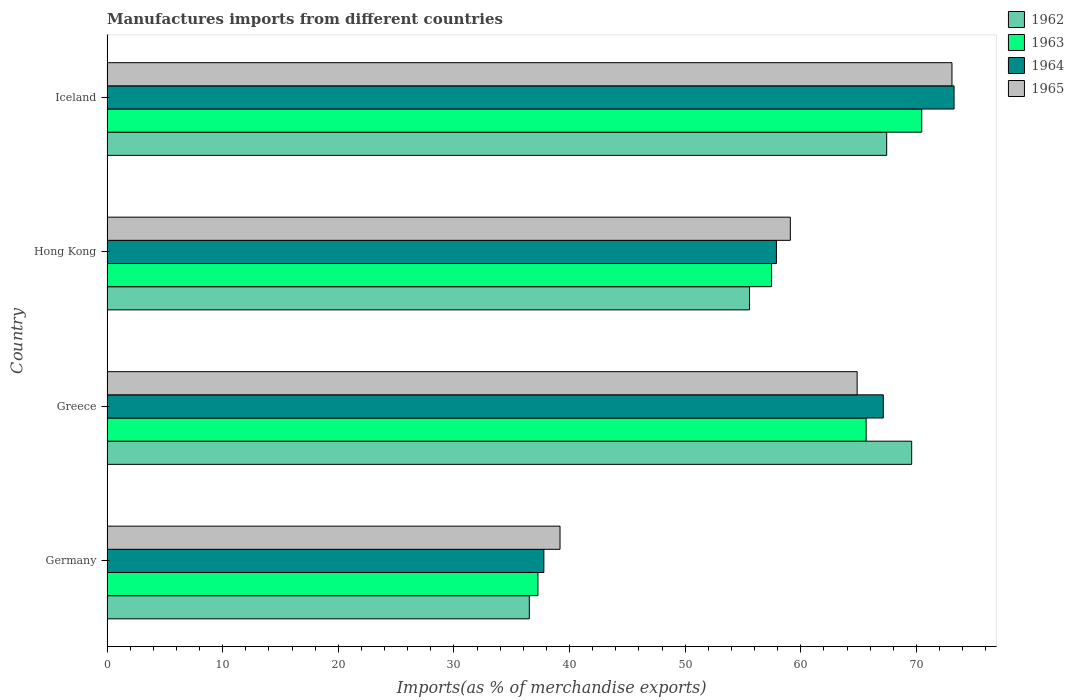How many different coloured bars are there?
Offer a terse response. 4. How many groups of bars are there?
Offer a very short reply. 4. Are the number of bars on each tick of the Y-axis equal?
Your answer should be very brief. Yes. What is the label of the 4th group of bars from the top?
Offer a very short reply. Germany. What is the percentage of imports to different countries in 1962 in Hong Kong?
Your response must be concise. 55.56. Across all countries, what is the maximum percentage of imports to different countries in 1963?
Give a very brief answer. 70.45. Across all countries, what is the minimum percentage of imports to different countries in 1965?
Provide a short and direct response. 39.18. In which country was the percentage of imports to different countries in 1963 maximum?
Provide a succinct answer. Iceland. In which country was the percentage of imports to different countries in 1965 minimum?
Provide a short and direct response. Germany. What is the total percentage of imports to different countries in 1965 in the graph?
Provide a succinct answer. 236.2. What is the difference between the percentage of imports to different countries in 1964 in Hong Kong and that in Iceland?
Provide a short and direct response. -15.36. What is the difference between the percentage of imports to different countries in 1964 in Greece and the percentage of imports to different countries in 1965 in Iceland?
Give a very brief answer. -5.94. What is the average percentage of imports to different countries in 1965 per country?
Offer a terse response. 59.05. What is the difference between the percentage of imports to different countries in 1962 and percentage of imports to different countries in 1965 in Hong Kong?
Your response must be concise. -3.53. In how many countries, is the percentage of imports to different countries in 1965 greater than 62 %?
Your answer should be very brief. 2. What is the ratio of the percentage of imports to different countries in 1962 in Hong Kong to that in Iceland?
Your response must be concise. 0.82. What is the difference between the highest and the second highest percentage of imports to different countries in 1962?
Your response must be concise. 2.16. What is the difference between the highest and the lowest percentage of imports to different countries in 1963?
Your response must be concise. 33.19. Is the sum of the percentage of imports to different countries in 1962 in Germany and Hong Kong greater than the maximum percentage of imports to different countries in 1963 across all countries?
Make the answer very short. Yes. What does the 1st bar from the top in Hong Kong represents?
Provide a succinct answer. 1965. What does the 3rd bar from the bottom in Greece represents?
Offer a very short reply. 1964. Is it the case that in every country, the sum of the percentage of imports to different countries in 1962 and percentage of imports to different countries in 1964 is greater than the percentage of imports to different countries in 1965?
Make the answer very short. Yes. Are all the bars in the graph horizontal?
Offer a terse response. Yes. How many countries are there in the graph?
Offer a very short reply. 4. What is the difference between two consecutive major ticks on the X-axis?
Offer a terse response. 10. Does the graph contain grids?
Keep it short and to the point. No. How are the legend labels stacked?
Offer a very short reply. Vertical. What is the title of the graph?
Offer a very short reply. Manufactures imports from different countries. Does "1980" appear as one of the legend labels in the graph?
Your response must be concise. No. What is the label or title of the X-axis?
Your answer should be compact. Imports(as % of merchandise exports). What is the label or title of the Y-axis?
Offer a very short reply. Country. What is the Imports(as % of merchandise exports) in 1962 in Germany?
Keep it short and to the point. 36.52. What is the Imports(as % of merchandise exports) in 1963 in Germany?
Your answer should be very brief. 37.26. What is the Imports(as % of merchandise exports) of 1964 in Germany?
Your answer should be very brief. 37.78. What is the Imports(as % of merchandise exports) in 1965 in Germany?
Keep it short and to the point. 39.18. What is the Imports(as % of merchandise exports) of 1962 in Greece?
Your response must be concise. 69.58. What is the Imports(as % of merchandise exports) of 1963 in Greece?
Your answer should be very brief. 65.65. What is the Imports(as % of merchandise exports) of 1964 in Greece?
Offer a terse response. 67.13. What is the Imports(as % of merchandise exports) of 1965 in Greece?
Keep it short and to the point. 64.87. What is the Imports(as % of merchandise exports) of 1962 in Hong Kong?
Your response must be concise. 55.56. What is the Imports(as % of merchandise exports) of 1963 in Hong Kong?
Offer a very short reply. 57.47. What is the Imports(as % of merchandise exports) in 1964 in Hong Kong?
Ensure brevity in your answer.  57.89. What is the Imports(as % of merchandise exports) of 1965 in Hong Kong?
Keep it short and to the point. 59.09. What is the Imports(as % of merchandise exports) of 1962 in Iceland?
Provide a short and direct response. 67.42. What is the Imports(as % of merchandise exports) in 1963 in Iceland?
Provide a succinct answer. 70.45. What is the Imports(as % of merchandise exports) in 1964 in Iceland?
Your answer should be compact. 73.25. What is the Imports(as % of merchandise exports) of 1965 in Iceland?
Provide a short and direct response. 73.07. Across all countries, what is the maximum Imports(as % of merchandise exports) in 1962?
Your response must be concise. 69.58. Across all countries, what is the maximum Imports(as % of merchandise exports) of 1963?
Give a very brief answer. 70.45. Across all countries, what is the maximum Imports(as % of merchandise exports) in 1964?
Offer a terse response. 73.25. Across all countries, what is the maximum Imports(as % of merchandise exports) in 1965?
Your response must be concise. 73.07. Across all countries, what is the minimum Imports(as % of merchandise exports) of 1962?
Ensure brevity in your answer.  36.52. Across all countries, what is the minimum Imports(as % of merchandise exports) of 1963?
Your answer should be very brief. 37.26. Across all countries, what is the minimum Imports(as % of merchandise exports) of 1964?
Your answer should be very brief. 37.78. Across all countries, what is the minimum Imports(as % of merchandise exports) in 1965?
Provide a short and direct response. 39.18. What is the total Imports(as % of merchandise exports) in 1962 in the graph?
Your response must be concise. 229.09. What is the total Imports(as % of merchandise exports) of 1963 in the graph?
Provide a succinct answer. 230.83. What is the total Imports(as % of merchandise exports) of 1964 in the graph?
Make the answer very short. 236.05. What is the total Imports(as % of merchandise exports) in 1965 in the graph?
Make the answer very short. 236.2. What is the difference between the Imports(as % of merchandise exports) of 1962 in Germany and that in Greece?
Your answer should be compact. -33.06. What is the difference between the Imports(as % of merchandise exports) of 1963 in Germany and that in Greece?
Ensure brevity in your answer.  -28.38. What is the difference between the Imports(as % of merchandise exports) in 1964 in Germany and that in Greece?
Offer a terse response. -29.35. What is the difference between the Imports(as % of merchandise exports) of 1965 in Germany and that in Greece?
Offer a terse response. -25.69. What is the difference between the Imports(as % of merchandise exports) of 1962 in Germany and that in Hong Kong?
Offer a very short reply. -19.04. What is the difference between the Imports(as % of merchandise exports) in 1963 in Germany and that in Hong Kong?
Your answer should be very brief. -20.2. What is the difference between the Imports(as % of merchandise exports) of 1964 in Germany and that in Hong Kong?
Your response must be concise. -20.11. What is the difference between the Imports(as % of merchandise exports) of 1965 in Germany and that in Hong Kong?
Give a very brief answer. -19.91. What is the difference between the Imports(as % of merchandise exports) of 1962 in Germany and that in Iceland?
Keep it short and to the point. -30.9. What is the difference between the Imports(as % of merchandise exports) in 1963 in Germany and that in Iceland?
Keep it short and to the point. -33.19. What is the difference between the Imports(as % of merchandise exports) in 1964 in Germany and that in Iceland?
Give a very brief answer. -35.47. What is the difference between the Imports(as % of merchandise exports) of 1965 in Germany and that in Iceland?
Offer a terse response. -33.89. What is the difference between the Imports(as % of merchandise exports) in 1962 in Greece and that in Hong Kong?
Your answer should be compact. 14.02. What is the difference between the Imports(as % of merchandise exports) in 1963 in Greece and that in Hong Kong?
Provide a succinct answer. 8.18. What is the difference between the Imports(as % of merchandise exports) in 1964 in Greece and that in Hong Kong?
Offer a very short reply. 9.24. What is the difference between the Imports(as % of merchandise exports) of 1965 in Greece and that in Hong Kong?
Give a very brief answer. 5.78. What is the difference between the Imports(as % of merchandise exports) of 1962 in Greece and that in Iceland?
Provide a short and direct response. 2.16. What is the difference between the Imports(as % of merchandise exports) in 1963 in Greece and that in Iceland?
Provide a short and direct response. -4.81. What is the difference between the Imports(as % of merchandise exports) in 1964 in Greece and that in Iceland?
Provide a succinct answer. -6.12. What is the difference between the Imports(as % of merchandise exports) of 1965 in Greece and that in Iceland?
Ensure brevity in your answer.  -8.2. What is the difference between the Imports(as % of merchandise exports) of 1962 in Hong Kong and that in Iceland?
Provide a succinct answer. -11.86. What is the difference between the Imports(as % of merchandise exports) in 1963 in Hong Kong and that in Iceland?
Keep it short and to the point. -12.98. What is the difference between the Imports(as % of merchandise exports) in 1964 in Hong Kong and that in Iceland?
Keep it short and to the point. -15.36. What is the difference between the Imports(as % of merchandise exports) of 1965 in Hong Kong and that in Iceland?
Ensure brevity in your answer.  -13.98. What is the difference between the Imports(as % of merchandise exports) in 1962 in Germany and the Imports(as % of merchandise exports) in 1963 in Greece?
Your response must be concise. -29.13. What is the difference between the Imports(as % of merchandise exports) in 1962 in Germany and the Imports(as % of merchandise exports) in 1964 in Greece?
Provide a succinct answer. -30.61. What is the difference between the Imports(as % of merchandise exports) in 1962 in Germany and the Imports(as % of merchandise exports) in 1965 in Greece?
Keep it short and to the point. -28.35. What is the difference between the Imports(as % of merchandise exports) in 1963 in Germany and the Imports(as % of merchandise exports) in 1964 in Greece?
Offer a terse response. -29.87. What is the difference between the Imports(as % of merchandise exports) of 1963 in Germany and the Imports(as % of merchandise exports) of 1965 in Greece?
Keep it short and to the point. -27.6. What is the difference between the Imports(as % of merchandise exports) in 1964 in Germany and the Imports(as % of merchandise exports) in 1965 in Greece?
Make the answer very short. -27.09. What is the difference between the Imports(as % of merchandise exports) of 1962 in Germany and the Imports(as % of merchandise exports) of 1963 in Hong Kong?
Provide a succinct answer. -20.95. What is the difference between the Imports(as % of merchandise exports) of 1962 in Germany and the Imports(as % of merchandise exports) of 1964 in Hong Kong?
Give a very brief answer. -21.37. What is the difference between the Imports(as % of merchandise exports) of 1962 in Germany and the Imports(as % of merchandise exports) of 1965 in Hong Kong?
Provide a short and direct response. -22.57. What is the difference between the Imports(as % of merchandise exports) in 1963 in Germany and the Imports(as % of merchandise exports) in 1964 in Hong Kong?
Your answer should be compact. -20.62. What is the difference between the Imports(as % of merchandise exports) of 1963 in Germany and the Imports(as % of merchandise exports) of 1965 in Hong Kong?
Your answer should be very brief. -21.83. What is the difference between the Imports(as % of merchandise exports) of 1964 in Germany and the Imports(as % of merchandise exports) of 1965 in Hong Kong?
Make the answer very short. -21.31. What is the difference between the Imports(as % of merchandise exports) in 1962 in Germany and the Imports(as % of merchandise exports) in 1963 in Iceland?
Provide a short and direct response. -33.93. What is the difference between the Imports(as % of merchandise exports) in 1962 in Germany and the Imports(as % of merchandise exports) in 1964 in Iceland?
Your answer should be very brief. -36.73. What is the difference between the Imports(as % of merchandise exports) in 1962 in Germany and the Imports(as % of merchandise exports) in 1965 in Iceland?
Make the answer very short. -36.55. What is the difference between the Imports(as % of merchandise exports) in 1963 in Germany and the Imports(as % of merchandise exports) in 1964 in Iceland?
Your response must be concise. -35.99. What is the difference between the Imports(as % of merchandise exports) in 1963 in Germany and the Imports(as % of merchandise exports) in 1965 in Iceland?
Offer a very short reply. -35.8. What is the difference between the Imports(as % of merchandise exports) of 1964 in Germany and the Imports(as % of merchandise exports) of 1965 in Iceland?
Make the answer very short. -35.29. What is the difference between the Imports(as % of merchandise exports) of 1962 in Greece and the Imports(as % of merchandise exports) of 1963 in Hong Kong?
Ensure brevity in your answer.  12.12. What is the difference between the Imports(as % of merchandise exports) of 1962 in Greece and the Imports(as % of merchandise exports) of 1964 in Hong Kong?
Keep it short and to the point. 11.7. What is the difference between the Imports(as % of merchandise exports) in 1962 in Greece and the Imports(as % of merchandise exports) in 1965 in Hong Kong?
Your answer should be very brief. 10.49. What is the difference between the Imports(as % of merchandise exports) of 1963 in Greece and the Imports(as % of merchandise exports) of 1964 in Hong Kong?
Offer a terse response. 7.76. What is the difference between the Imports(as % of merchandise exports) of 1963 in Greece and the Imports(as % of merchandise exports) of 1965 in Hong Kong?
Your answer should be compact. 6.56. What is the difference between the Imports(as % of merchandise exports) in 1964 in Greece and the Imports(as % of merchandise exports) in 1965 in Hong Kong?
Your answer should be compact. 8.04. What is the difference between the Imports(as % of merchandise exports) in 1962 in Greece and the Imports(as % of merchandise exports) in 1963 in Iceland?
Your response must be concise. -0.87. What is the difference between the Imports(as % of merchandise exports) of 1962 in Greece and the Imports(as % of merchandise exports) of 1964 in Iceland?
Ensure brevity in your answer.  -3.67. What is the difference between the Imports(as % of merchandise exports) in 1962 in Greece and the Imports(as % of merchandise exports) in 1965 in Iceland?
Give a very brief answer. -3.48. What is the difference between the Imports(as % of merchandise exports) in 1963 in Greece and the Imports(as % of merchandise exports) in 1964 in Iceland?
Provide a succinct answer. -7.6. What is the difference between the Imports(as % of merchandise exports) in 1963 in Greece and the Imports(as % of merchandise exports) in 1965 in Iceland?
Keep it short and to the point. -7.42. What is the difference between the Imports(as % of merchandise exports) of 1964 in Greece and the Imports(as % of merchandise exports) of 1965 in Iceland?
Your answer should be very brief. -5.94. What is the difference between the Imports(as % of merchandise exports) in 1962 in Hong Kong and the Imports(as % of merchandise exports) in 1963 in Iceland?
Your answer should be very brief. -14.89. What is the difference between the Imports(as % of merchandise exports) in 1962 in Hong Kong and the Imports(as % of merchandise exports) in 1964 in Iceland?
Offer a terse response. -17.69. What is the difference between the Imports(as % of merchandise exports) in 1962 in Hong Kong and the Imports(as % of merchandise exports) in 1965 in Iceland?
Ensure brevity in your answer.  -17.51. What is the difference between the Imports(as % of merchandise exports) of 1963 in Hong Kong and the Imports(as % of merchandise exports) of 1964 in Iceland?
Your answer should be very brief. -15.78. What is the difference between the Imports(as % of merchandise exports) of 1963 in Hong Kong and the Imports(as % of merchandise exports) of 1965 in Iceland?
Your response must be concise. -15.6. What is the difference between the Imports(as % of merchandise exports) of 1964 in Hong Kong and the Imports(as % of merchandise exports) of 1965 in Iceland?
Your answer should be very brief. -15.18. What is the average Imports(as % of merchandise exports) of 1962 per country?
Keep it short and to the point. 57.27. What is the average Imports(as % of merchandise exports) in 1963 per country?
Your answer should be compact. 57.71. What is the average Imports(as % of merchandise exports) of 1964 per country?
Keep it short and to the point. 59.01. What is the average Imports(as % of merchandise exports) in 1965 per country?
Provide a short and direct response. 59.05. What is the difference between the Imports(as % of merchandise exports) of 1962 and Imports(as % of merchandise exports) of 1963 in Germany?
Your answer should be very brief. -0.75. What is the difference between the Imports(as % of merchandise exports) of 1962 and Imports(as % of merchandise exports) of 1964 in Germany?
Offer a very short reply. -1.26. What is the difference between the Imports(as % of merchandise exports) of 1962 and Imports(as % of merchandise exports) of 1965 in Germany?
Give a very brief answer. -2.66. What is the difference between the Imports(as % of merchandise exports) in 1963 and Imports(as % of merchandise exports) in 1964 in Germany?
Your answer should be very brief. -0.51. What is the difference between the Imports(as % of merchandise exports) in 1963 and Imports(as % of merchandise exports) in 1965 in Germany?
Your answer should be very brief. -1.91. What is the difference between the Imports(as % of merchandise exports) in 1964 and Imports(as % of merchandise exports) in 1965 in Germany?
Provide a short and direct response. -1.4. What is the difference between the Imports(as % of merchandise exports) in 1962 and Imports(as % of merchandise exports) in 1963 in Greece?
Provide a succinct answer. 3.94. What is the difference between the Imports(as % of merchandise exports) in 1962 and Imports(as % of merchandise exports) in 1964 in Greece?
Give a very brief answer. 2.45. What is the difference between the Imports(as % of merchandise exports) in 1962 and Imports(as % of merchandise exports) in 1965 in Greece?
Offer a terse response. 4.72. What is the difference between the Imports(as % of merchandise exports) in 1963 and Imports(as % of merchandise exports) in 1964 in Greece?
Offer a very short reply. -1.48. What is the difference between the Imports(as % of merchandise exports) in 1963 and Imports(as % of merchandise exports) in 1965 in Greece?
Offer a very short reply. 0.78. What is the difference between the Imports(as % of merchandise exports) in 1964 and Imports(as % of merchandise exports) in 1965 in Greece?
Ensure brevity in your answer.  2.26. What is the difference between the Imports(as % of merchandise exports) of 1962 and Imports(as % of merchandise exports) of 1963 in Hong Kong?
Your answer should be compact. -1.91. What is the difference between the Imports(as % of merchandise exports) in 1962 and Imports(as % of merchandise exports) in 1964 in Hong Kong?
Your answer should be compact. -2.33. What is the difference between the Imports(as % of merchandise exports) of 1962 and Imports(as % of merchandise exports) of 1965 in Hong Kong?
Your answer should be very brief. -3.53. What is the difference between the Imports(as % of merchandise exports) in 1963 and Imports(as % of merchandise exports) in 1964 in Hong Kong?
Your answer should be very brief. -0.42. What is the difference between the Imports(as % of merchandise exports) of 1963 and Imports(as % of merchandise exports) of 1965 in Hong Kong?
Your response must be concise. -1.62. What is the difference between the Imports(as % of merchandise exports) in 1964 and Imports(as % of merchandise exports) in 1965 in Hong Kong?
Give a very brief answer. -1.2. What is the difference between the Imports(as % of merchandise exports) of 1962 and Imports(as % of merchandise exports) of 1963 in Iceland?
Make the answer very short. -3.03. What is the difference between the Imports(as % of merchandise exports) of 1962 and Imports(as % of merchandise exports) of 1964 in Iceland?
Provide a short and direct response. -5.83. What is the difference between the Imports(as % of merchandise exports) of 1962 and Imports(as % of merchandise exports) of 1965 in Iceland?
Give a very brief answer. -5.64. What is the difference between the Imports(as % of merchandise exports) of 1963 and Imports(as % of merchandise exports) of 1964 in Iceland?
Offer a terse response. -2.8. What is the difference between the Imports(as % of merchandise exports) of 1963 and Imports(as % of merchandise exports) of 1965 in Iceland?
Offer a terse response. -2.61. What is the difference between the Imports(as % of merchandise exports) of 1964 and Imports(as % of merchandise exports) of 1965 in Iceland?
Make the answer very short. 0.18. What is the ratio of the Imports(as % of merchandise exports) of 1962 in Germany to that in Greece?
Ensure brevity in your answer.  0.52. What is the ratio of the Imports(as % of merchandise exports) in 1963 in Germany to that in Greece?
Make the answer very short. 0.57. What is the ratio of the Imports(as % of merchandise exports) of 1964 in Germany to that in Greece?
Ensure brevity in your answer.  0.56. What is the ratio of the Imports(as % of merchandise exports) in 1965 in Germany to that in Greece?
Offer a very short reply. 0.6. What is the ratio of the Imports(as % of merchandise exports) in 1962 in Germany to that in Hong Kong?
Provide a succinct answer. 0.66. What is the ratio of the Imports(as % of merchandise exports) in 1963 in Germany to that in Hong Kong?
Keep it short and to the point. 0.65. What is the ratio of the Imports(as % of merchandise exports) in 1964 in Germany to that in Hong Kong?
Your response must be concise. 0.65. What is the ratio of the Imports(as % of merchandise exports) in 1965 in Germany to that in Hong Kong?
Offer a terse response. 0.66. What is the ratio of the Imports(as % of merchandise exports) of 1962 in Germany to that in Iceland?
Make the answer very short. 0.54. What is the ratio of the Imports(as % of merchandise exports) of 1963 in Germany to that in Iceland?
Offer a terse response. 0.53. What is the ratio of the Imports(as % of merchandise exports) in 1964 in Germany to that in Iceland?
Offer a terse response. 0.52. What is the ratio of the Imports(as % of merchandise exports) of 1965 in Germany to that in Iceland?
Your answer should be compact. 0.54. What is the ratio of the Imports(as % of merchandise exports) in 1962 in Greece to that in Hong Kong?
Give a very brief answer. 1.25. What is the ratio of the Imports(as % of merchandise exports) in 1963 in Greece to that in Hong Kong?
Keep it short and to the point. 1.14. What is the ratio of the Imports(as % of merchandise exports) in 1964 in Greece to that in Hong Kong?
Your answer should be very brief. 1.16. What is the ratio of the Imports(as % of merchandise exports) of 1965 in Greece to that in Hong Kong?
Give a very brief answer. 1.1. What is the ratio of the Imports(as % of merchandise exports) in 1962 in Greece to that in Iceland?
Your answer should be compact. 1.03. What is the ratio of the Imports(as % of merchandise exports) in 1963 in Greece to that in Iceland?
Ensure brevity in your answer.  0.93. What is the ratio of the Imports(as % of merchandise exports) in 1964 in Greece to that in Iceland?
Offer a very short reply. 0.92. What is the ratio of the Imports(as % of merchandise exports) in 1965 in Greece to that in Iceland?
Provide a short and direct response. 0.89. What is the ratio of the Imports(as % of merchandise exports) of 1962 in Hong Kong to that in Iceland?
Make the answer very short. 0.82. What is the ratio of the Imports(as % of merchandise exports) in 1963 in Hong Kong to that in Iceland?
Make the answer very short. 0.82. What is the ratio of the Imports(as % of merchandise exports) in 1964 in Hong Kong to that in Iceland?
Make the answer very short. 0.79. What is the ratio of the Imports(as % of merchandise exports) of 1965 in Hong Kong to that in Iceland?
Keep it short and to the point. 0.81. What is the difference between the highest and the second highest Imports(as % of merchandise exports) of 1962?
Ensure brevity in your answer.  2.16. What is the difference between the highest and the second highest Imports(as % of merchandise exports) in 1963?
Your answer should be compact. 4.81. What is the difference between the highest and the second highest Imports(as % of merchandise exports) in 1964?
Your response must be concise. 6.12. What is the difference between the highest and the second highest Imports(as % of merchandise exports) in 1965?
Offer a very short reply. 8.2. What is the difference between the highest and the lowest Imports(as % of merchandise exports) of 1962?
Offer a very short reply. 33.06. What is the difference between the highest and the lowest Imports(as % of merchandise exports) in 1963?
Provide a short and direct response. 33.19. What is the difference between the highest and the lowest Imports(as % of merchandise exports) of 1964?
Your answer should be very brief. 35.47. What is the difference between the highest and the lowest Imports(as % of merchandise exports) in 1965?
Offer a very short reply. 33.89. 